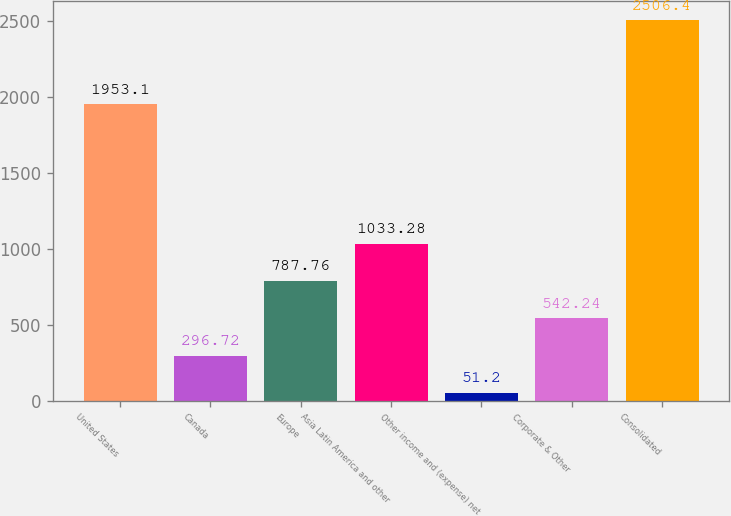Convert chart. <chart><loc_0><loc_0><loc_500><loc_500><bar_chart><fcel>United States<fcel>Canada<fcel>Europe<fcel>Asia Latin America and other<fcel>Other income and (expense) net<fcel>Corporate & Other<fcel>Consolidated<nl><fcel>1953.1<fcel>296.72<fcel>787.76<fcel>1033.28<fcel>51.2<fcel>542.24<fcel>2506.4<nl></chart> 